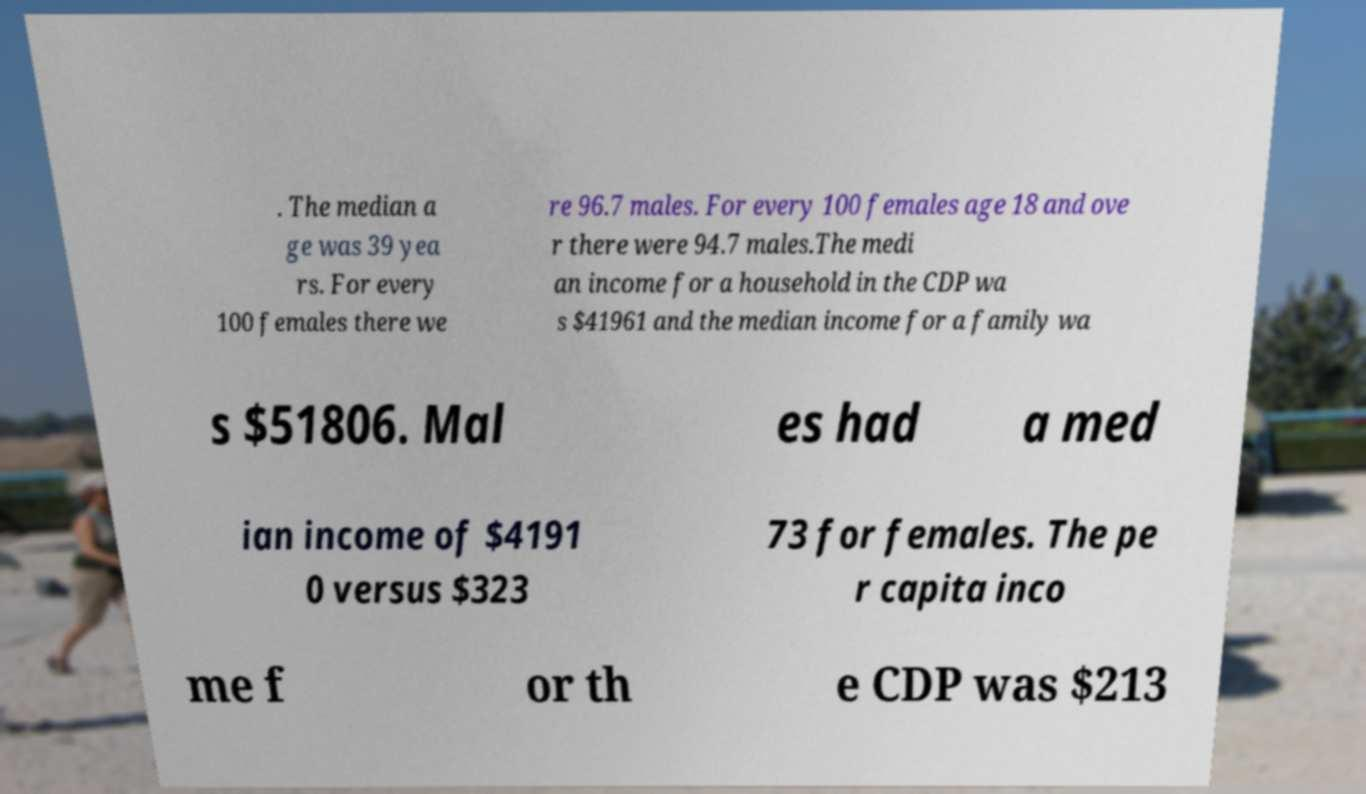There's text embedded in this image that I need extracted. Can you transcribe it verbatim? . The median a ge was 39 yea rs. For every 100 females there we re 96.7 males. For every 100 females age 18 and ove r there were 94.7 males.The medi an income for a household in the CDP wa s $41961 and the median income for a family wa s $51806. Mal es had a med ian income of $4191 0 versus $323 73 for females. The pe r capita inco me f or th e CDP was $213 